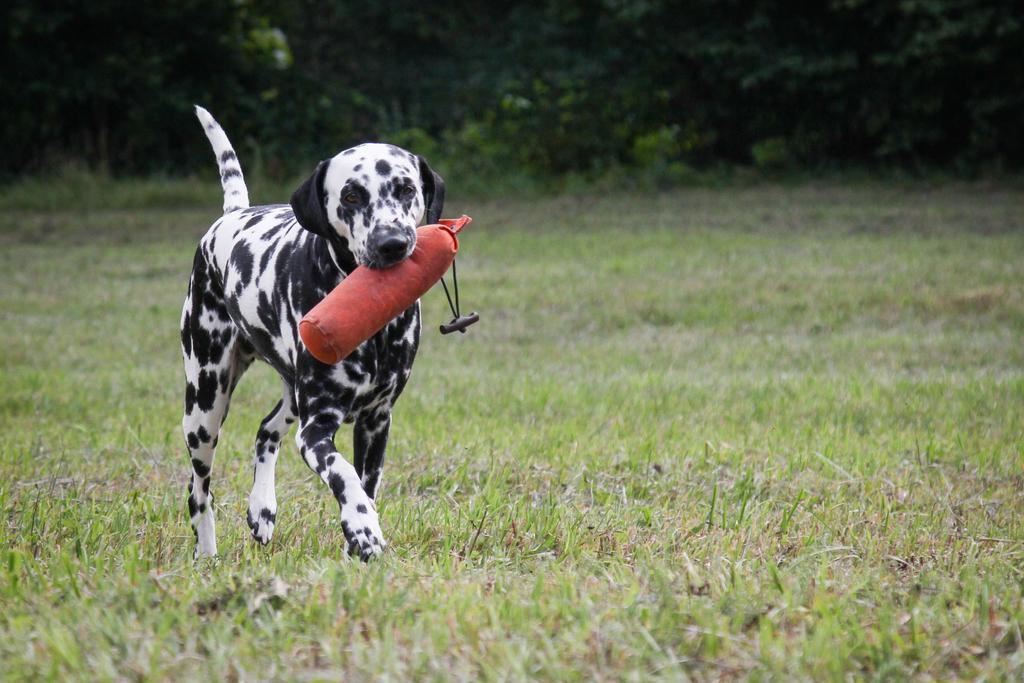Please provide a concise description of this image. In this image, we can see a dog holding an object in the mouth and walking on the grass. In the background, we can see some plants and trees. 